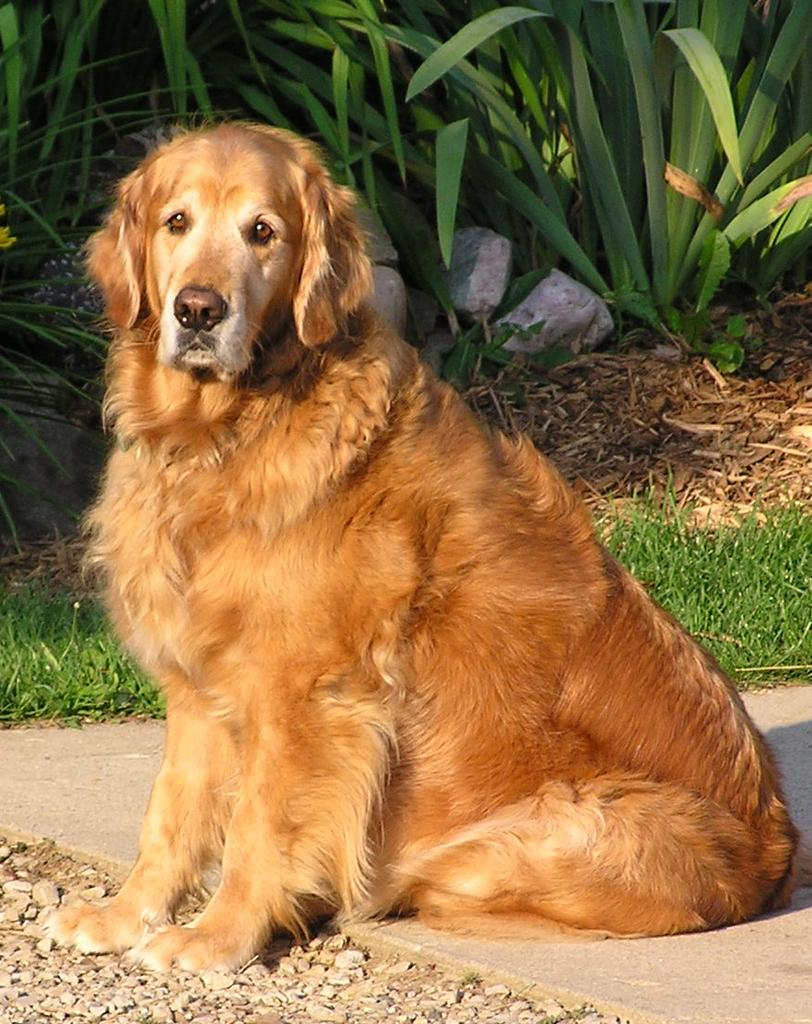What type of animal can be seen in the image? There is a dog in the image. What other living organisms are present in the image? There are plants in the image. What is the texture of the ground in the image? The ground is grassy in the image. What type of natural features can be seen in the image? There are rocks in the image. What type of bead is being used as a decoration on the dog's apparel in the image? There is no bead or apparel present on the dog in the image. What type of glass object can be seen in the image? There is no glass object present in the image. 